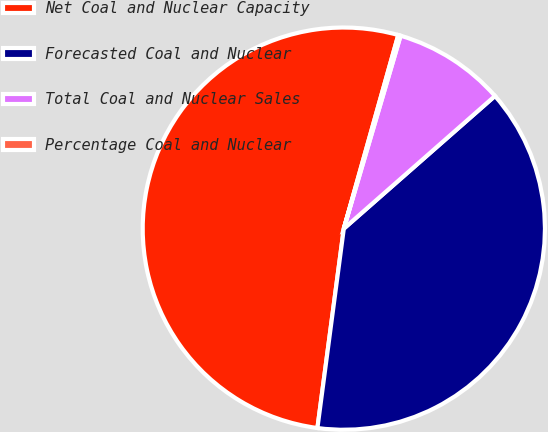<chart> <loc_0><loc_0><loc_500><loc_500><pie_chart><fcel>Net Coal and Nuclear Capacity<fcel>Forecasted Coal and Nuclear<fcel>Total Coal and Nuclear Sales<fcel>Percentage Coal and Nuclear<nl><fcel>52.27%<fcel>38.56%<fcel>8.98%<fcel>0.19%<nl></chart> 